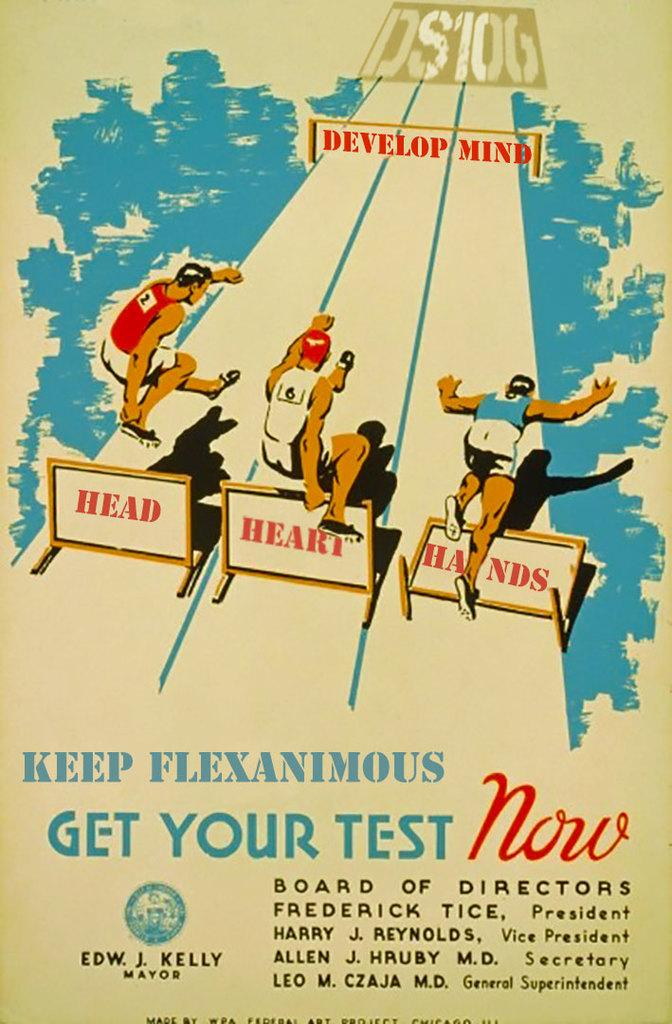Provide a one-sentence caption for the provided image. Poster board of get your test now for your health. 